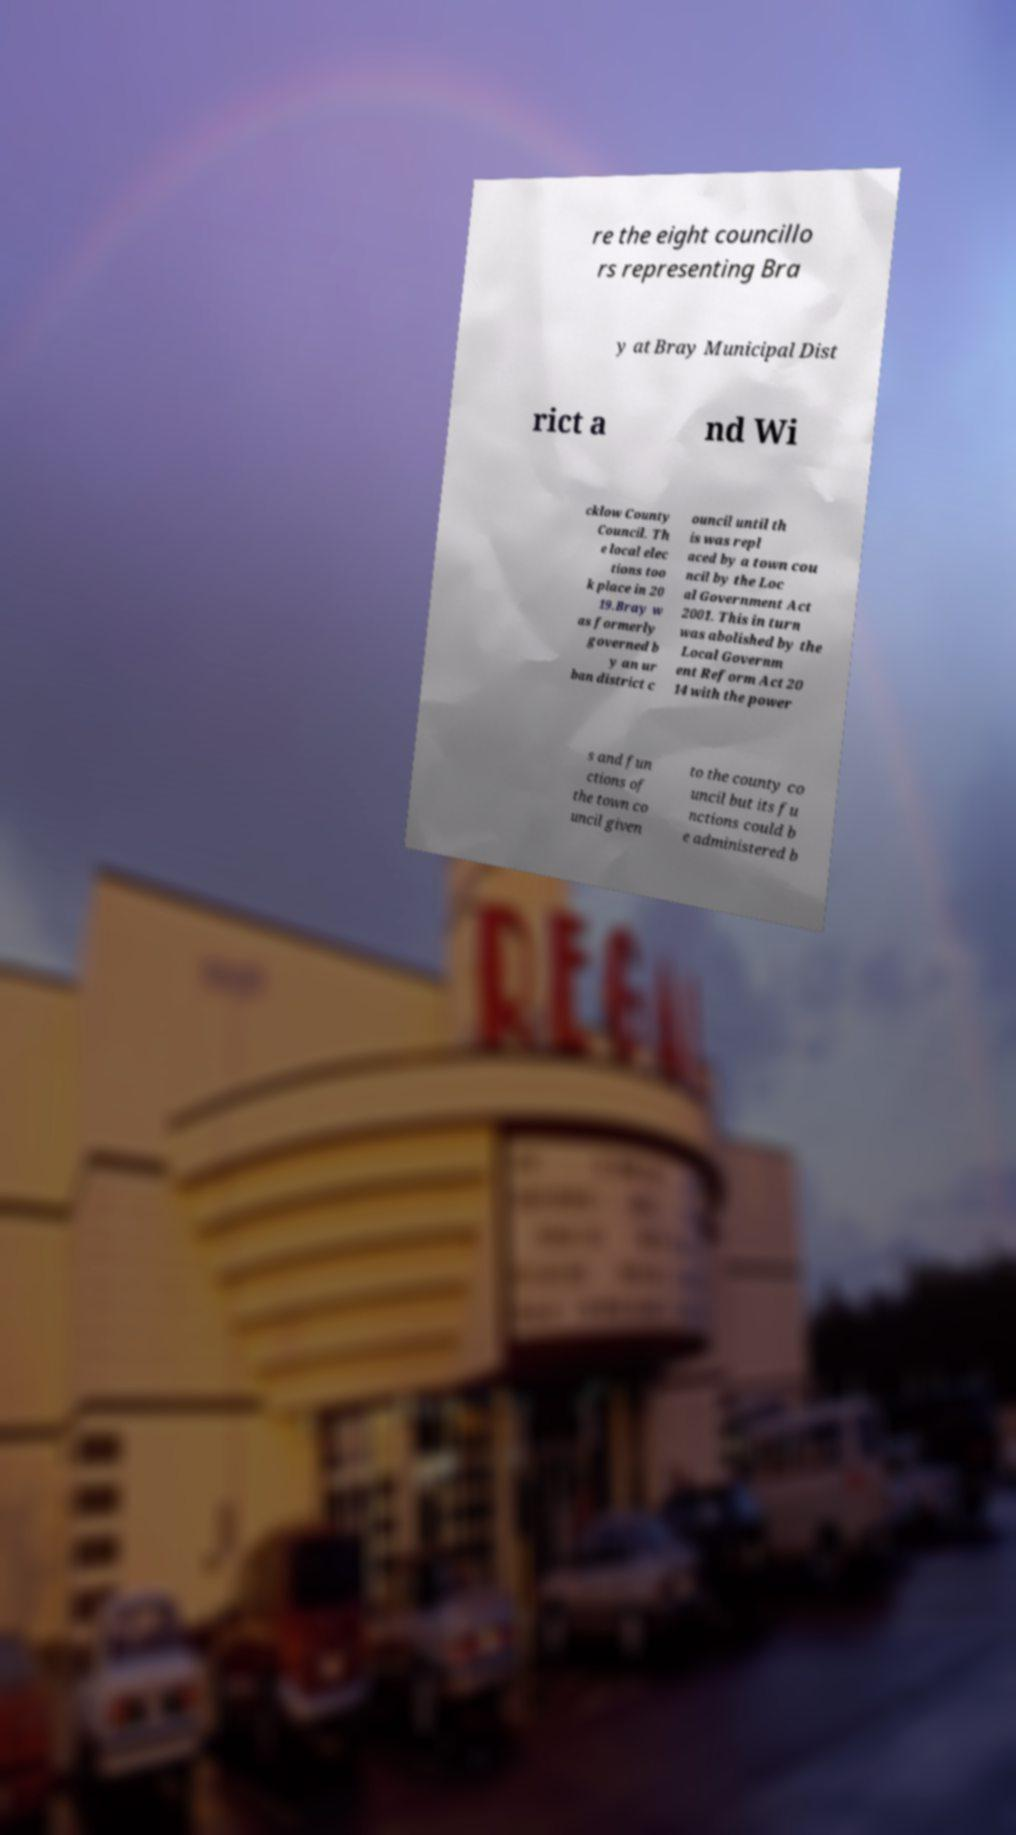Can you read and provide the text displayed in the image?This photo seems to have some interesting text. Can you extract and type it out for me? re the eight councillo rs representing Bra y at Bray Municipal Dist rict a nd Wi cklow County Council. Th e local elec tions too k place in 20 19.Bray w as formerly governed b y an ur ban district c ouncil until th is was repl aced by a town cou ncil by the Loc al Government Act 2001. This in turn was abolished by the Local Governm ent Reform Act 20 14 with the power s and fun ctions of the town co uncil given to the county co uncil but its fu nctions could b e administered b 